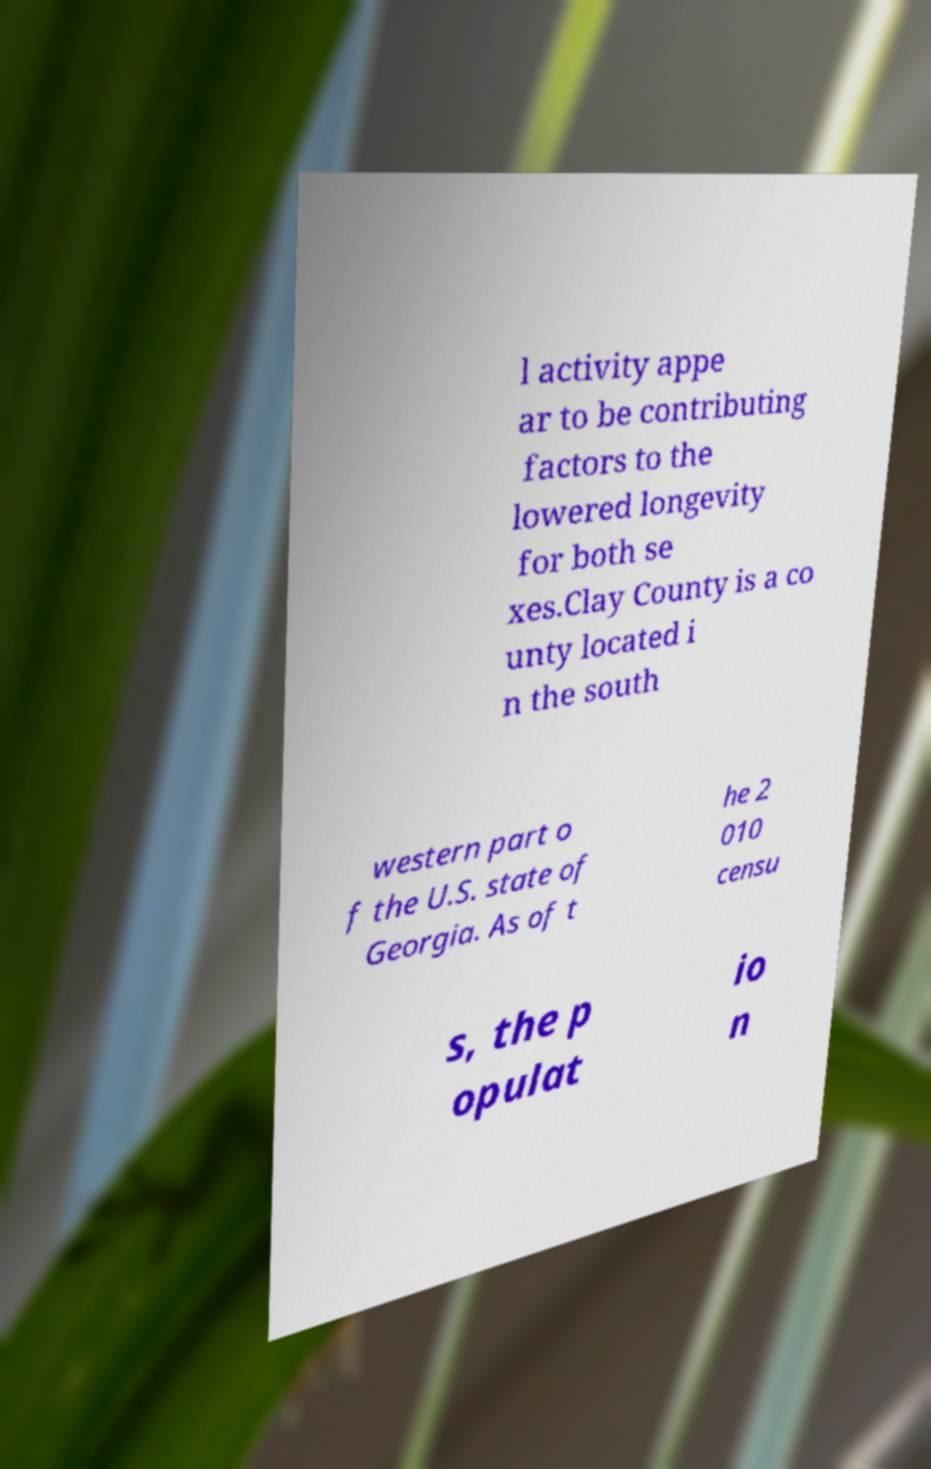Can you read and provide the text displayed in the image?This photo seems to have some interesting text. Can you extract and type it out for me? l activity appe ar to be contributing factors to the lowered longevity for both se xes.Clay County is a co unty located i n the south western part o f the U.S. state of Georgia. As of t he 2 010 censu s, the p opulat io n 